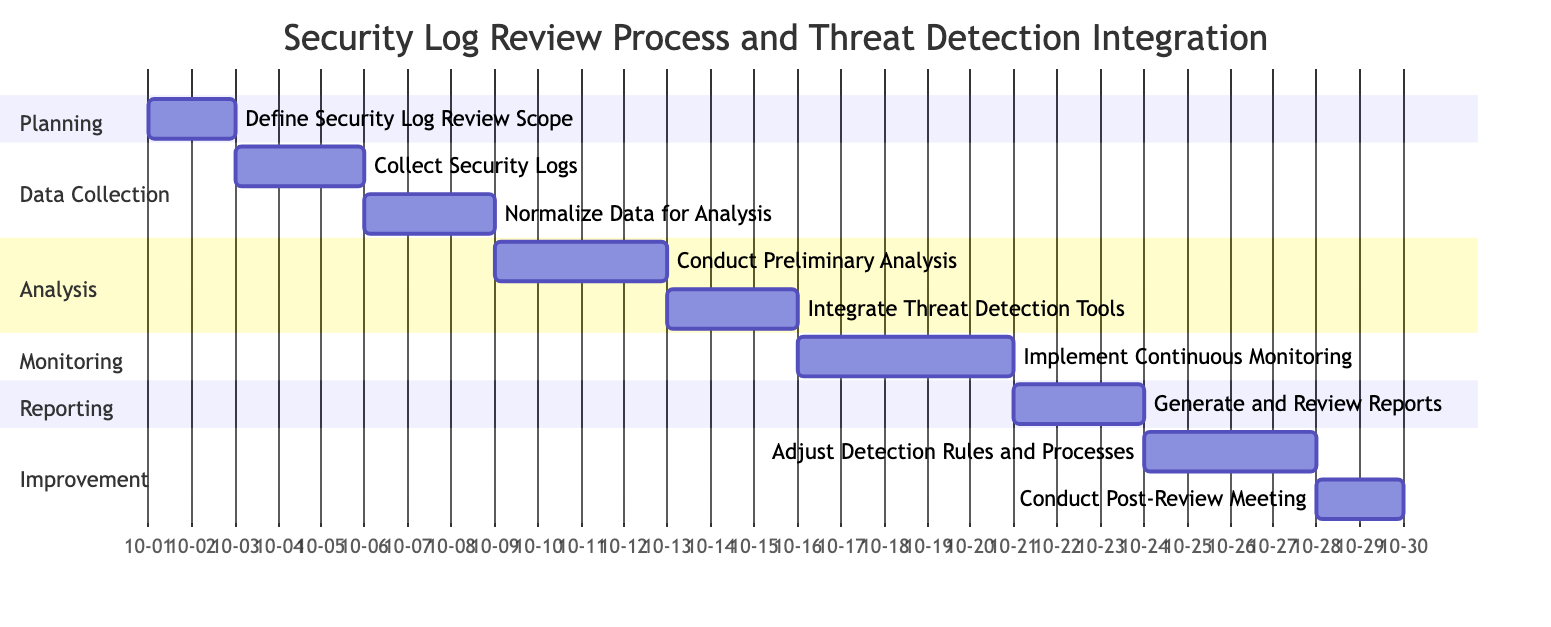What is the duration of the task "Integrate Threat Detection Tools"? The task "Integrate Threat Detection Tools" is indicated in the diagram, and its duration is specified as 3 days. This can be found in the section when looking at the end date minus the start date for that task.
Answer: 3 days How many tasks are listed under the "Monitoring" section? The "Monitoring" section contains one task, which is "Implement Continuous Monitoring." This is determined by counting the tasks in that particular section.
Answer: 1 What task begins immediately after "Conduct Preliminary Analysis"? The diagram shows that after "Conduct Preliminary Analysis," the next task is "Integrate Threat Detection Tools," which follows directly in the workflow, as the end date of the former task aligns with the start date of the latter.
Answer: Integrate Threat Detection Tools What is the start date of the task "Conduct Post-Review Meeting"? The diagram specifies that the task "Conduct Post-Review Meeting" starts on October 28, 2023. This can be found by looking at the defined start date next to the task name in the last section.
Answer: 2023-10-28 What is the total duration of the entire workflow from beginning to end? The entire workflow starts with "Define Security Log Review Scope" on October 1, 2023, and ends with "Conduct Post-Review Meeting," which concludes on October 29, 2023. The total duration is the difference between these two dates, counting all days in between.
Answer: 29 days Which task has the longest duration, and what is that duration? When reviewing the tasks and their durations, "Implement Continuous Monitoring" has the longest duration at 5 days. This is found by comparing all the specified durations for each task in the visual structure.
Answer: 5 days How many sections are in the Gantt Chart? The Gantt Chart is divided into six distinct sections labeled "Planning," "Data Collection," "Analysis," "Monitoring," "Reporting," and "Improvement." Counting these sections gives the total.
Answer: 6 What is the end date of the "Generate and Review Reports" task? The end date for the task "Generate and Review Reports" is shown as October 23, 2023, by locating the task in the reporting section and checking the specified end date next to it.
Answer: 2023-10-23 